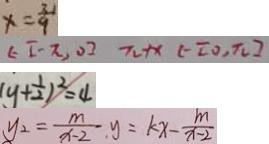Convert formula to latex. <formula><loc_0><loc_0><loc_500><loc_500>x = \frac { 3 } { 9 } 
 \epsilon [ - \pi , 0 ] \pi + x ( - [ 0 , \pi ] 
 ( y + \frac { 1 } { 2 } ) ^ { 2 } = 4 
 y _ { 2 } = \frac { m } { x - 2 } . y = k x - \frac { m } { x - 2 }</formula> 